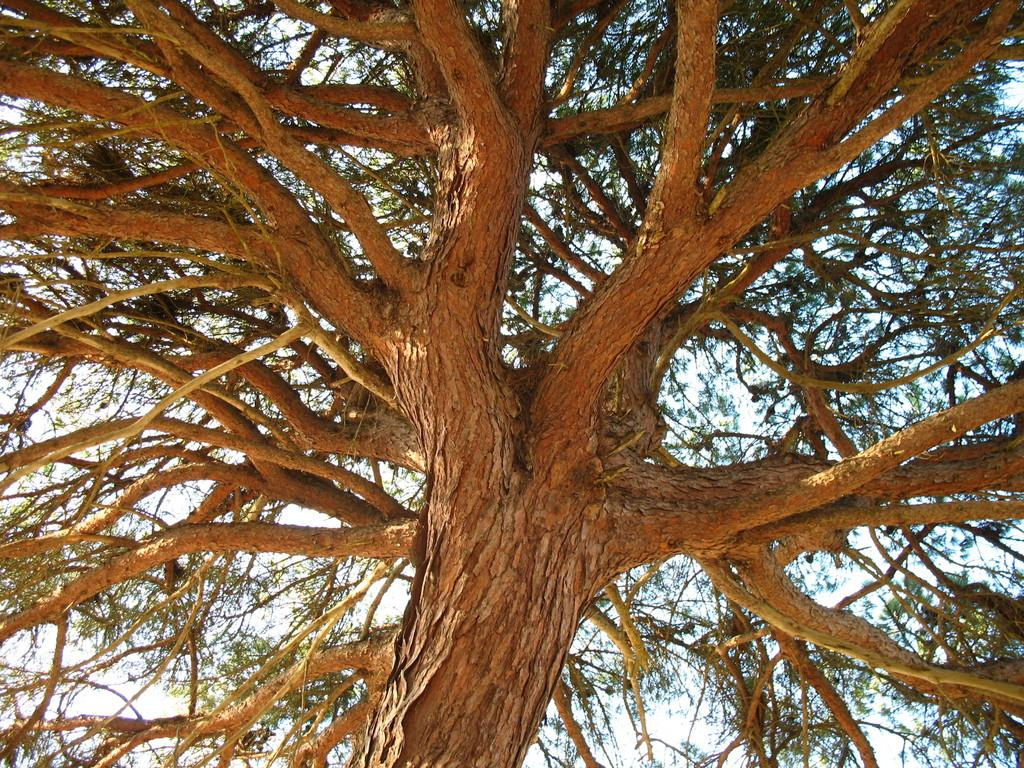What type of plant can be seen in the image? There is a tree in the image. What can be seen in the background of the image? The sky is visible in the background of the image. What type of thread is being used to create the tree in the image? There is no thread present in the image, as the tree is a natural object and not a man-made creation. 